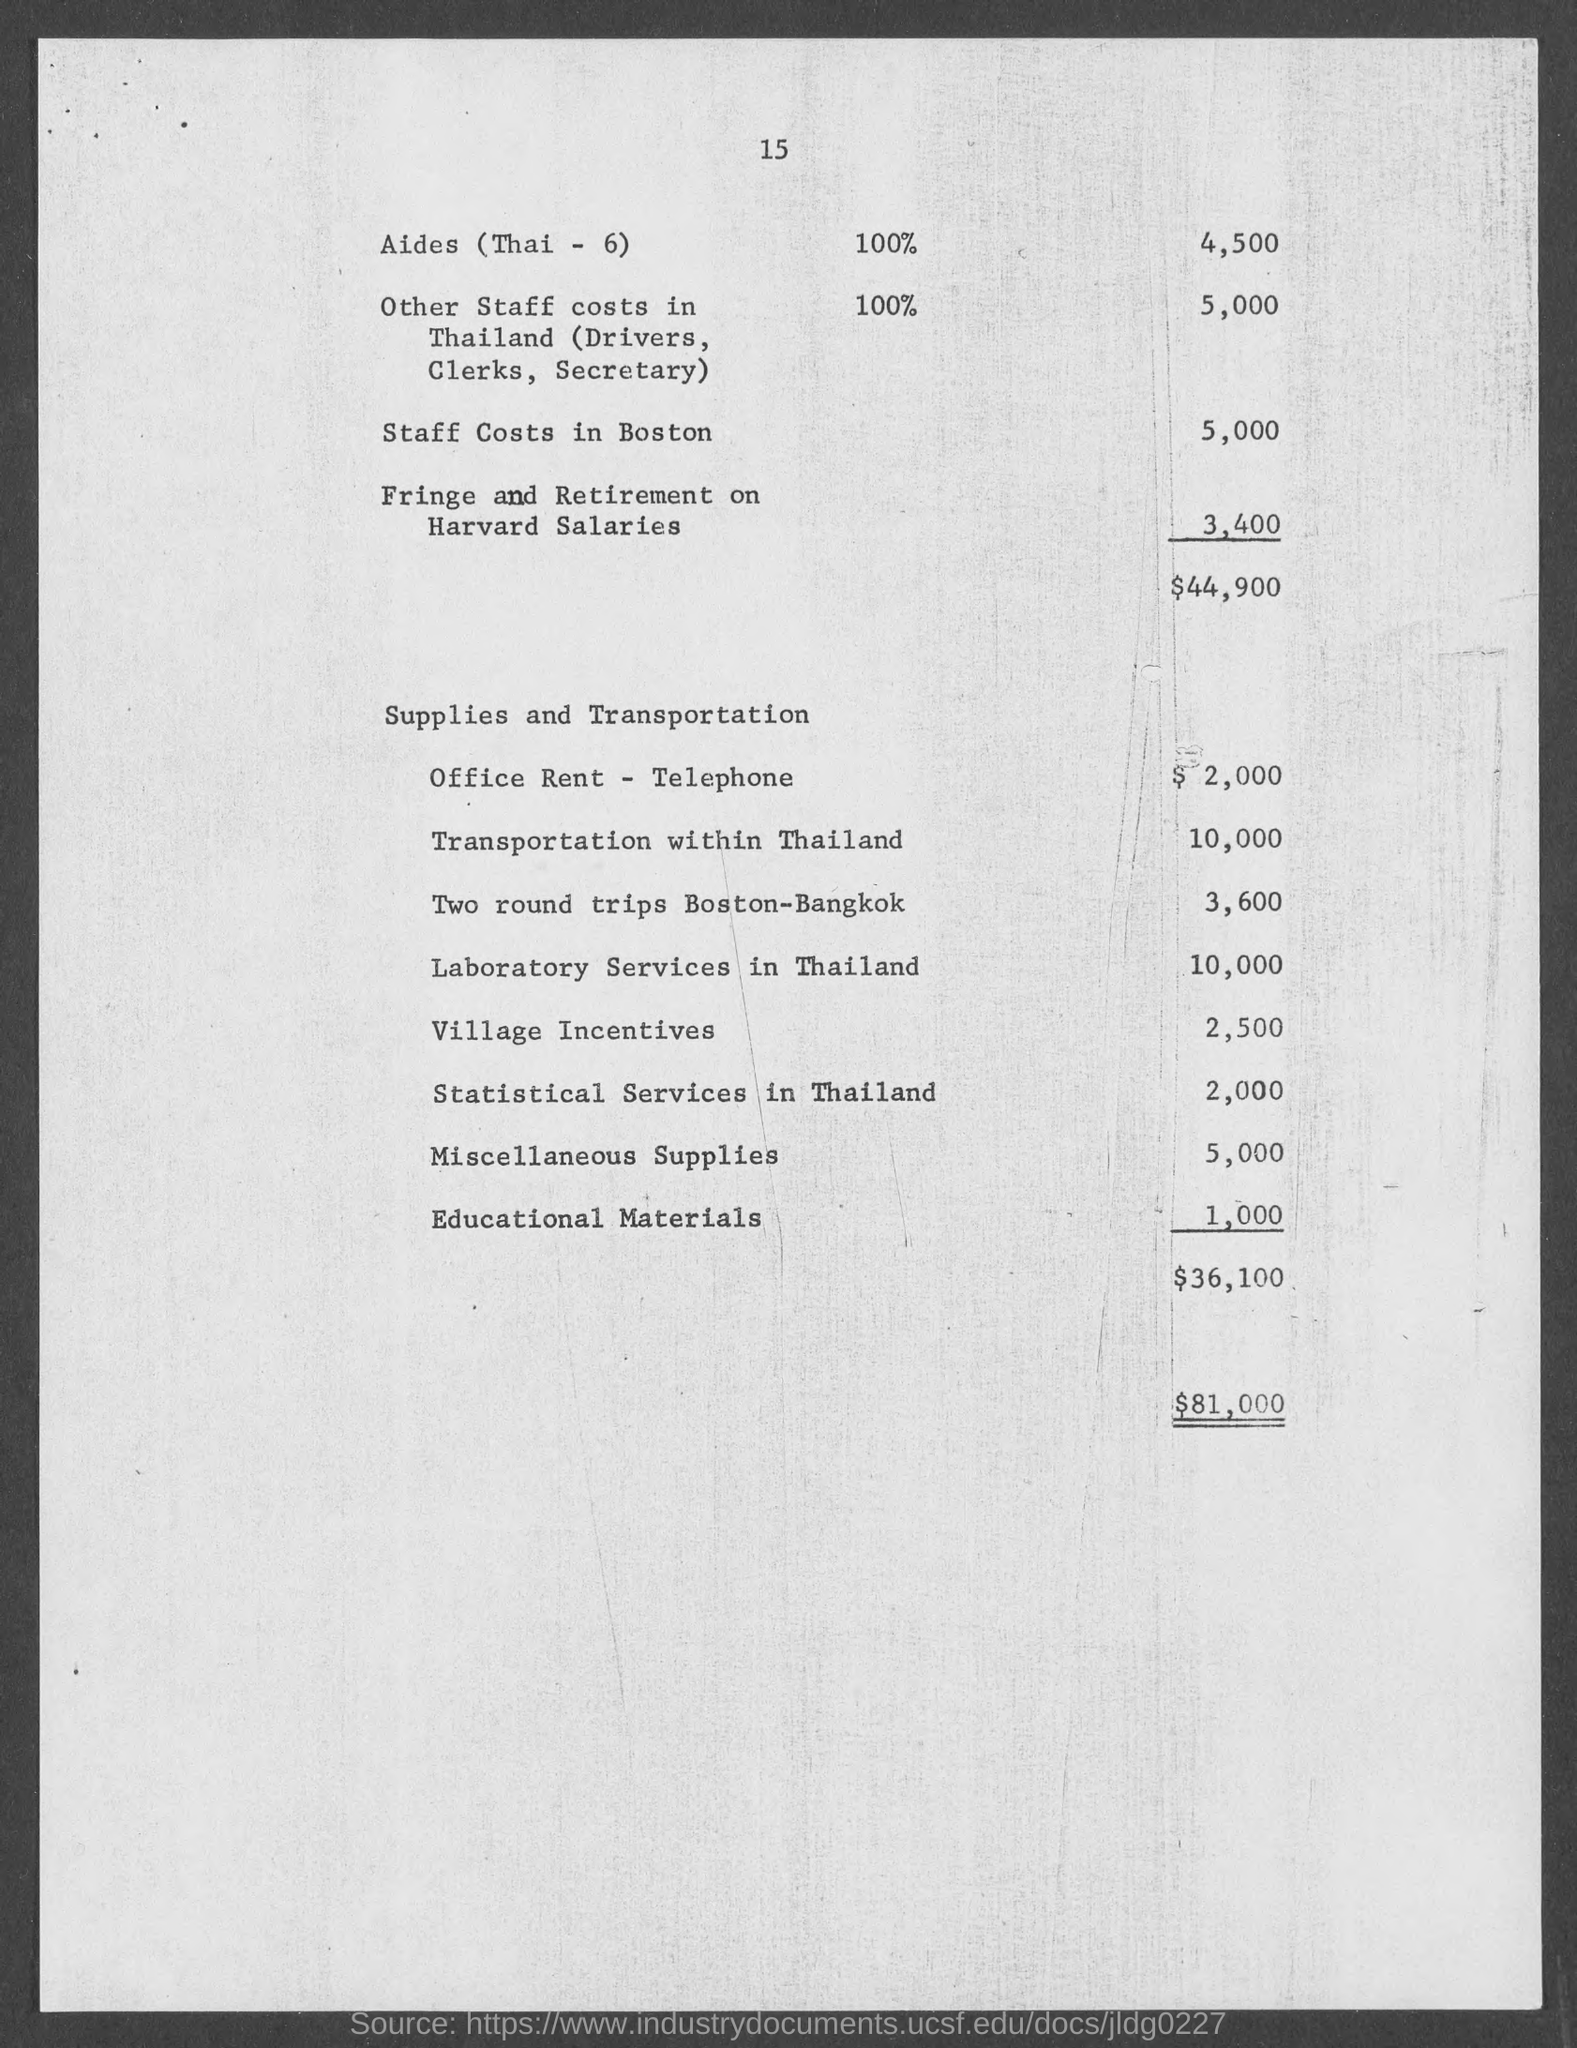Specify some key components in this picture. The staff costs in Boston are estimated to be approximately 5,000. The cost for statistical services in Thailand is approximately 2,000. The cost for laboratory services in Thailand is 10,000. The cost of transportation within Thailand is approximately 10,000 Thai Baht. Miscellaneous supplies have a cost of 5,000. 